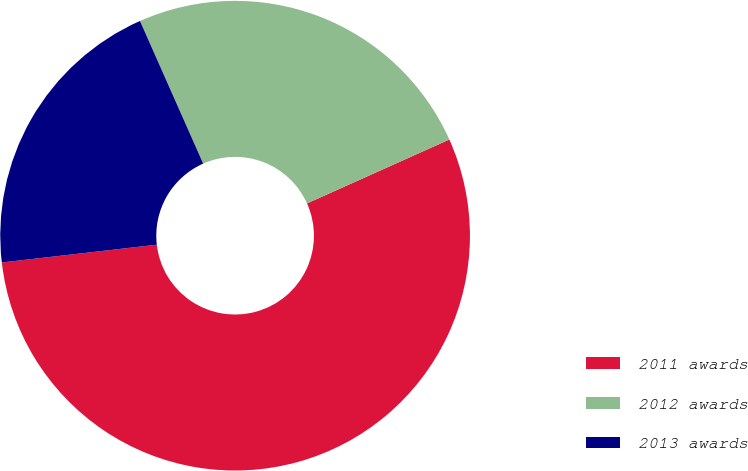<chart> <loc_0><loc_0><loc_500><loc_500><pie_chart><fcel>2011 awards<fcel>2012 awards<fcel>2013 awards<nl><fcel>54.89%<fcel>24.92%<fcel>20.18%<nl></chart> 